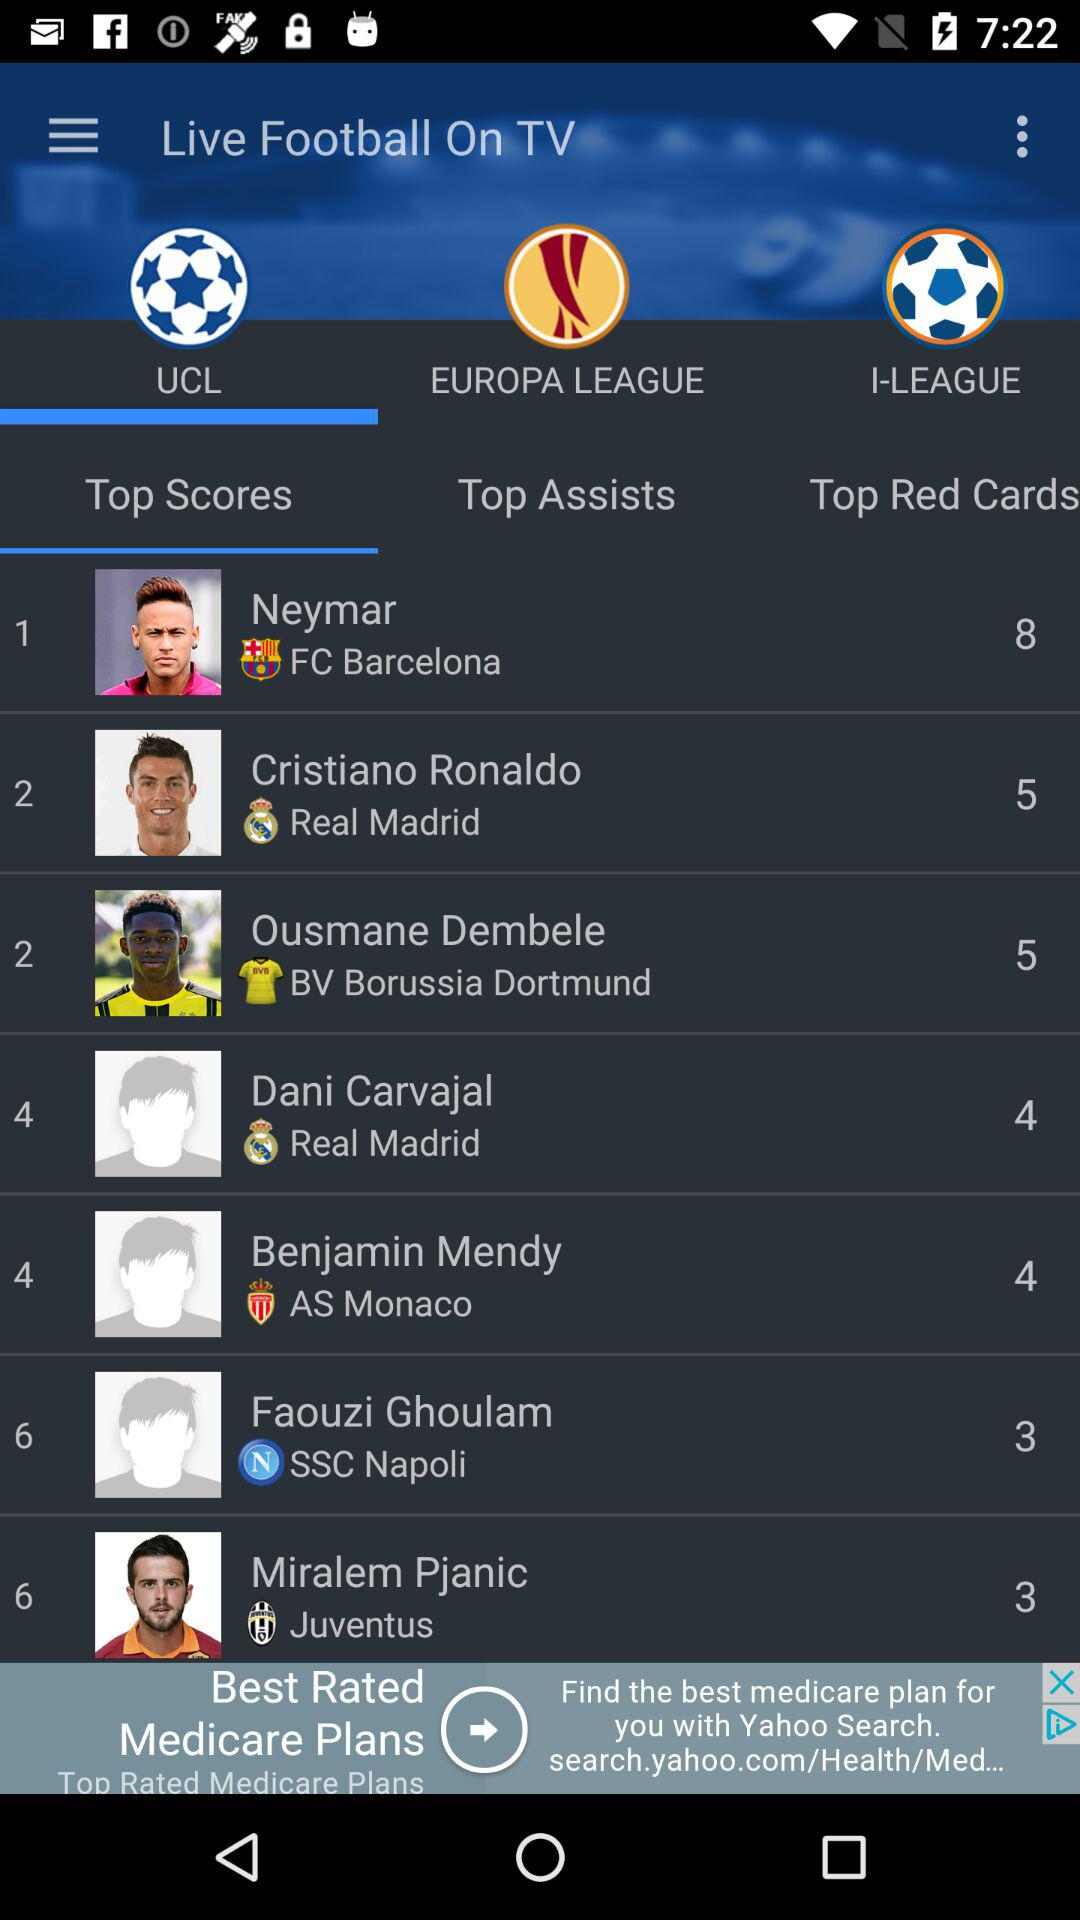What is the score of Cristiano Ronaldo? The score of Cristiano Ronaldo is 5. 